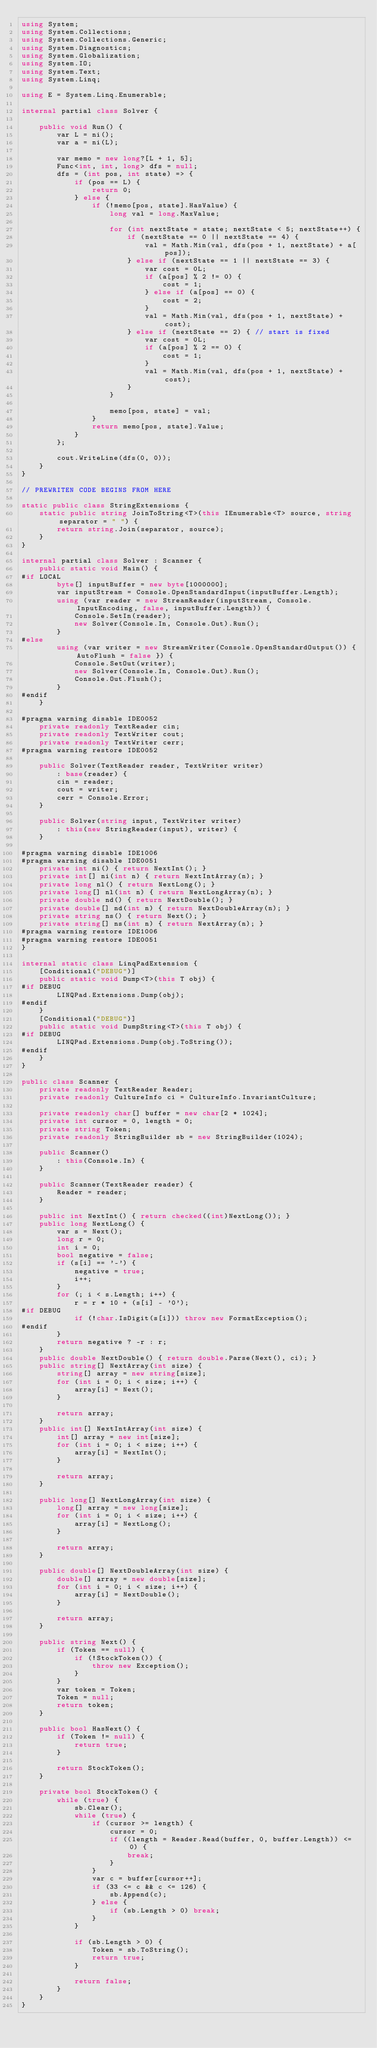<code> <loc_0><loc_0><loc_500><loc_500><_C#_>using System;
using System.Collections;
using System.Collections.Generic;
using System.Diagnostics;
using System.Globalization;
using System.IO;
using System.Text;
using System.Linq;

using E = System.Linq.Enumerable;

internal partial class Solver {

    public void Run() {
        var L = ni();
        var a = ni(L);

        var memo = new long?[L + 1, 5];
        Func<int, int, long> dfs = null;
        dfs = (int pos, int state) => {
            if (pos == L) {
                return 0;
            } else {
                if (!memo[pos, state].HasValue) {
                    long val = long.MaxValue;

                    for (int nextState = state; nextState < 5; nextState++) {
                        if (nextState == 0 || nextState == 4) {
                            val = Math.Min(val, dfs(pos + 1, nextState) + a[pos]);
                        } else if (nextState == 1 || nextState == 3) {
                            var cost = 0L;
                            if (a[pos] % 2 != 0) {
                                cost = 1;
                            } else if (a[pos] == 0) {
                                cost = 2;
                            }
                            val = Math.Min(val, dfs(pos + 1, nextState) + cost);
                        } else if (nextState == 2) { // start is fixed
                            var cost = 0L;
                            if (a[pos] % 2 == 0) {
                                cost = 1;
                            }
                            val = Math.Min(val, dfs(pos + 1, nextState) + cost);
                        }
                    }

                    memo[pos, state] = val;
                }
                return memo[pos, state].Value;
            }
        };

        cout.WriteLine(dfs(0, 0));
    }
}

// PREWRITEN CODE BEGINS FROM HERE

static public class StringExtensions {
    static public string JoinToString<T>(this IEnumerable<T> source, string separator = " ") {
        return string.Join(separator, source);
    }
}

internal partial class Solver : Scanner {
    public static void Main() {
#if LOCAL
        byte[] inputBuffer = new byte[1000000];
        var inputStream = Console.OpenStandardInput(inputBuffer.Length);
        using (var reader = new StreamReader(inputStream, Console.InputEncoding, false, inputBuffer.Length)) {
            Console.SetIn(reader);
            new Solver(Console.In, Console.Out).Run();
        }
#else
        using (var writer = new StreamWriter(Console.OpenStandardOutput()) { AutoFlush = false }) {
            Console.SetOut(writer);
            new Solver(Console.In, Console.Out).Run();
            Console.Out.Flush();
        }
#endif
    }

#pragma warning disable IDE0052
    private readonly TextReader cin;
    private readonly TextWriter cout;
    private readonly TextWriter cerr;
#pragma warning restore IDE0052

    public Solver(TextReader reader, TextWriter writer)
        : base(reader) {
        cin = reader;
        cout = writer;
        cerr = Console.Error;
    }

    public Solver(string input, TextWriter writer)
        : this(new StringReader(input), writer) {
    }

#pragma warning disable IDE1006
#pragma warning disable IDE0051
    private int ni() { return NextInt(); }
    private int[] ni(int n) { return NextIntArray(n); }
    private long nl() { return NextLong(); }
    private long[] nl(int n) { return NextLongArray(n); }
    private double nd() { return NextDouble(); }
    private double[] nd(int n) { return NextDoubleArray(n); }
    private string ns() { return Next(); }
    private string[] ns(int n) { return NextArray(n); }
#pragma warning restore IDE1006
#pragma warning restore IDE0051
}

internal static class LinqPadExtension {
    [Conditional("DEBUG")]
    public static void Dump<T>(this T obj) {
#if DEBUG
        LINQPad.Extensions.Dump(obj);
#endif
    }
    [Conditional("DEBUG")]
    public static void DumpString<T>(this T obj) {
#if DEBUG
        LINQPad.Extensions.Dump(obj.ToString());
#endif
    }
}

public class Scanner {
    private readonly TextReader Reader;
    private readonly CultureInfo ci = CultureInfo.InvariantCulture;

    private readonly char[] buffer = new char[2 * 1024];
    private int cursor = 0, length = 0;
    private string Token;
    private readonly StringBuilder sb = new StringBuilder(1024);

    public Scanner()
        : this(Console.In) {
    }

    public Scanner(TextReader reader) {
        Reader = reader;
    }

    public int NextInt() { return checked((int)NextLong()); }
    public long NextLong() {
        var s = Next();
        long r = 0;
        int i = 0;
        bool negative = false;
        if (s[i] == '-') {
            negative = true;
            i++;
        }
        for (; i < s.Length; i++) {
            r = r * 10 + (s[i] - '0');
#if DEBUG
            if (!char.IsDigit(s[i])) throw new FormatException();
#endif
        }
        return negative ? -r : r;
    }
    public double NextDouble() { return double.Parse(Next(), ci); }
    public string[] NextArray(int size) {
        string[] array = new string[size];
        for (int i = 0; i < size; i++) {
            array[i] = Next();
        }

        return array;
    }
    public int[] NextIntArray(int size) {
        int[] array = new int[size];
        for (int i = 0; i < size; i++) {
            array[i] = NextInt();
        }

        return array;
    }

    public long[] NextLongArray(int size) {
        long[] array = new long[size];
        for (int i = 0; i < size; i++) {
            array[i] = NextLong();
        }

        return array;
    }

    public double[] NextDoubleArray(int size) {
        double[] array = new double[size];
        for (int i = 0; i < size; i++) {
            array[i] = NextDouble();
        }

        return array;
    }

    public string Next() {
        if (Token == null) {
            if (!StockToken()) {
                throw new Exception();
            }
        }
        var token = Token;
        Token = null;
        return token;
    }

    public bool HasNext() {
        if (Token != null) {
            return true;
        }

        return StockToken();
    }

    private bool StockToken() {
        while (true) {
            sb.Clear();
            while (true) {
                if (cursor >= length) {
                    cursor = 0;
                    if ((length = Reader.Read(buffer, 0, buffer.Length)) <= 0) {
                        break;
                    }
                }
                var c = buffer[cursor++];
                if (33 <= c && c <= 126) {
                    sb.Append(c);
                } else {
                    if (sb.Length > 0) break;
                }
            }

            if (sb.Length > 0) {
                Token = sb.ToString();
                return true;
            }

            return false;
        }
    }
}</code> 